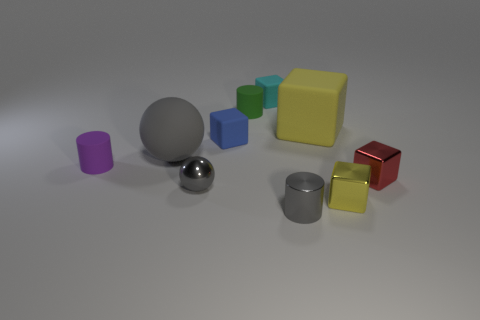Subtract 1 cylinders. How many cylinders are left? 2 Subtract all red cubes. How many cubes are left? 4 Subtract all tiny shiny cubes. How many cubes are left? 3 Subtract all cyan blocks. Subtract all purple spheres. How many blocks are left? 4 Subtract all cylinders. How many objects are left? 7 Subtract all small gray cylinders. Subtract all small metal cylinders. How many objects are left? 8 Add 3 green objects. How many green objects are left? 4 Add 4 red metallic things. How many red metallic things exist? 5 Subtract 1 blue blocks. How many objects are left? 9 